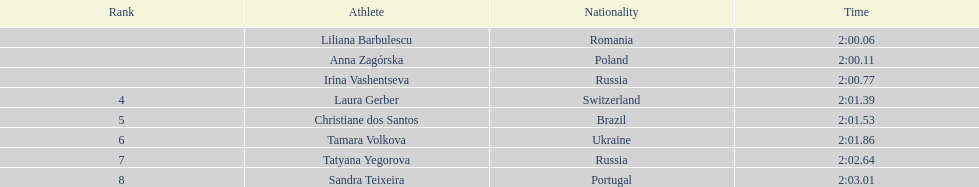What was anna zagorska's time when she achieved the second position? 2:00.11. 